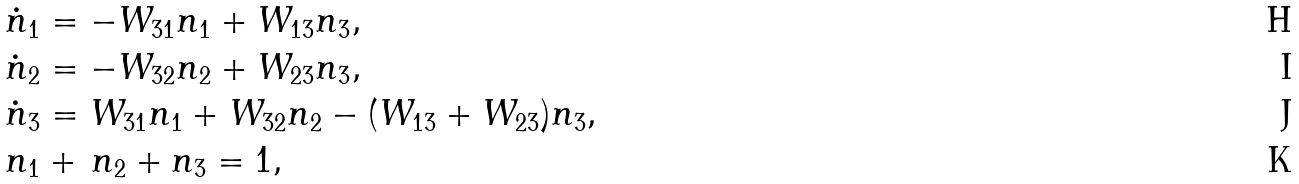<formula> <loc_0><loc_0><loc_500><loc_500>\dot { n } _ { 1 } & = - W _ { 3 1 } n _ { 1 } + W _ { 1 3 } n _ { 3 } , \\ \dot { n } _ { 2 } & = - W _ { 3 2 } n _ { 2 } + W _ { 2 3 } n _ { 3 } , \\ \dot { n } _ { 3 } & = W _ { 3 1 } n _ { 1 } + W _ { 3 2 } n _ { 2 } - ( W _ { 1 3 } + W _ { 2 3 } ) n _ { 3 } , \\ n _ { 1 } & + \, n _ { 2 } + n _ { 3 } = 1 ,</formula> 